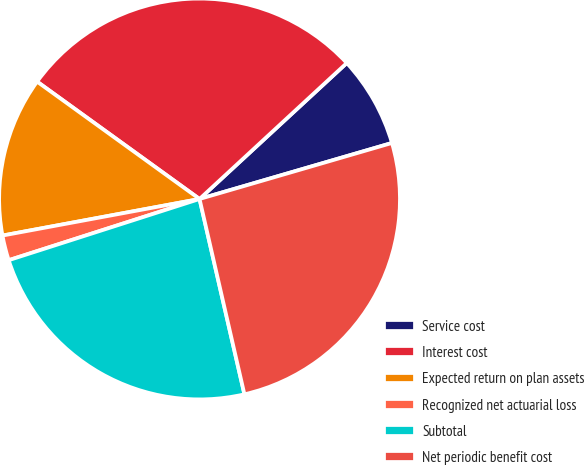Convert chart. <chart><loc_0><loc_0><loc_500><loc_500><pie_chart><fcel>Service cost<fcel>Interest cost<fcel>Expected return on plan assets<fcel>Recognized net actuarial loss<fcel>Subtotal<fcel>Net periodic benefit cost<nl><fcel>7.36%<fcel>28.18%<fcel>12.88%<fcel>2.02%<fcel>23.66%<fcel>25.92%<nl></chart> 